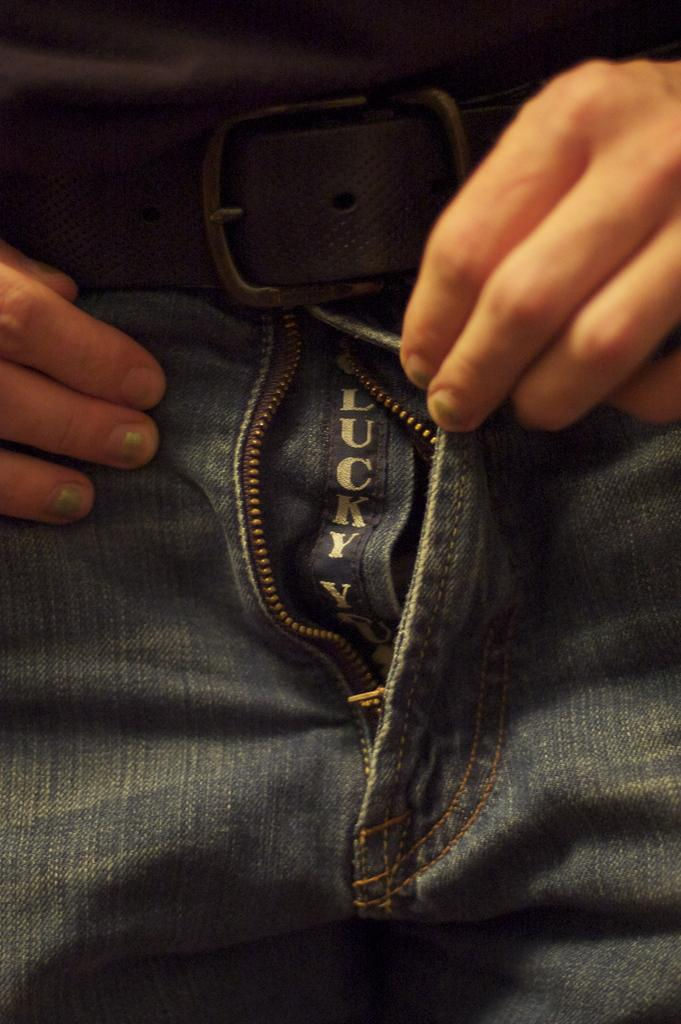What body part is visible in the image? There are hands of a person in the image. What is the person holding in the image? There is a black color belt in the image. What type of clothing is the person wearing? The person is wearing jeans in the image. Is there any text or design on the jeans? Yes, something is written on the jeans in the image. Can you see a chicken playing volleyball in the image? No, there is no chicken or volleyball present in the image. 